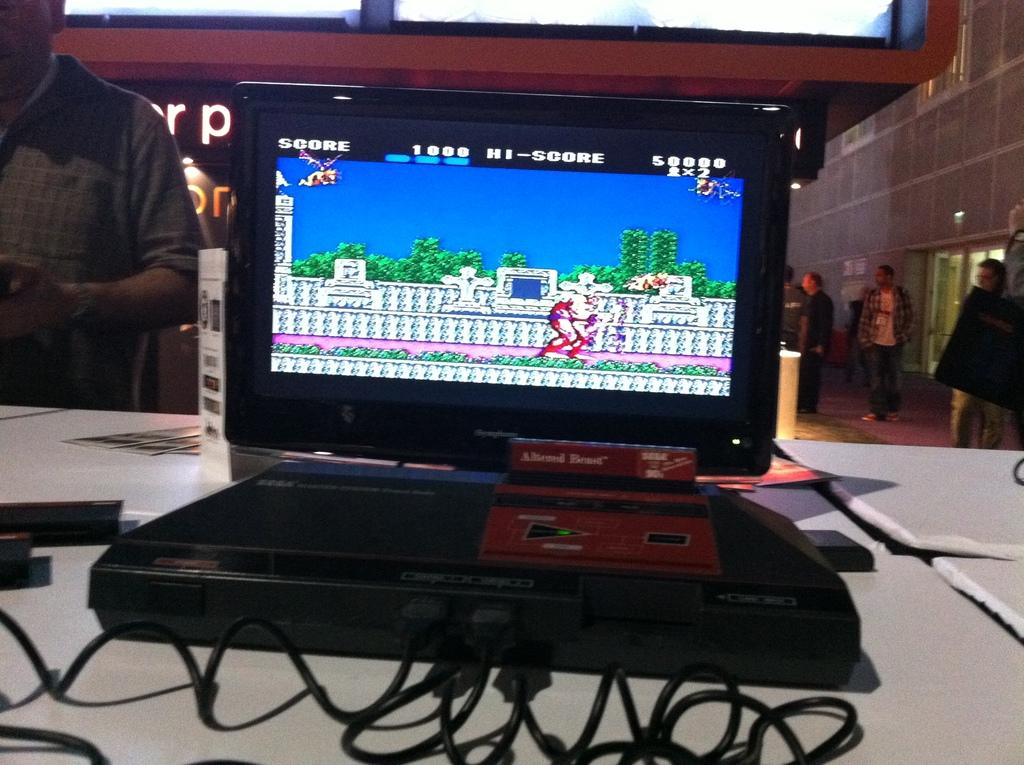What is this player's score?
Ensure brevity in your answer.  1000. 